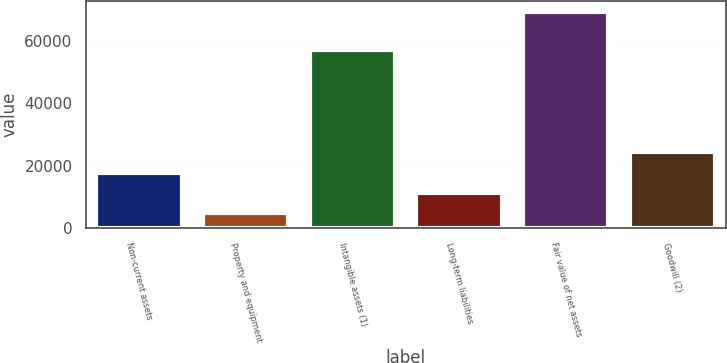Convert chart to OTSL. <chart><loc_0><loc_0><loc_500><loc_500><bar_chart><fcel>Non-current assets<fcel>Property and equipment<fcel>Intangible assets (1)<fcel>Long-term liabilities<fcel>Fair value of net assets<fcel>Goodwill (2)<nl><fcel>17824.6<fcel>4966<fcel>56876<fcel>11395.3<fcel>69259<fcel>24253.9<nl></chart> 